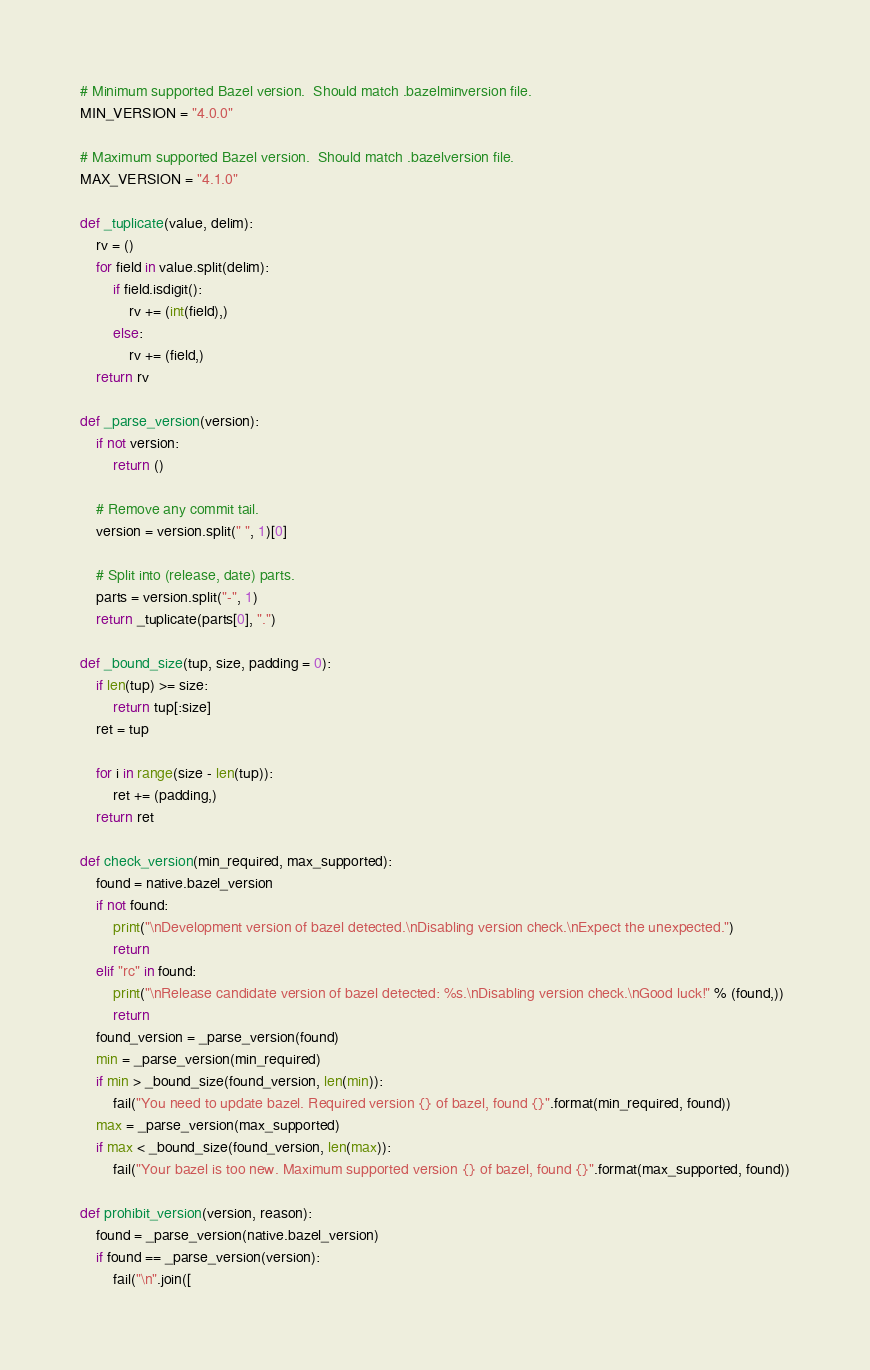<code> <loc_0><loc_0><loc_500><loc_500><_Python_># Minimum supported Bazel version.  Should match .bazelminversion file.
MIN_VERSION = "4.0.0"

# Maximum supported Bazel version.  Should match .bazelversion file.
MAX_VERSION = "4.1.0"

def _tuplicate(value, delim):
    rv = ()
    for field in value.split(delim):
        if field.isdigit():
            rv += (int(field),)
        else:
            rv += (field,)
    return rv

def _parse_version(version):
    if not version:
        return ()

    # Remove any commit tail.
    version = version.split(" ", 1)[0]

    # Split into (release, date) parts.
    parts = version.split("-", 1)
    return _tuplicate(parts[0], ".")

def _bound_size(tup, size, padding = 0):
    if len(tup) >= size:
        return tup[:size]
    ret = tup

    for i in range(size - len(tup)):
        ret += (padding,)
    return ret

def check_version(min_required, max_supported):
    found = native.bazel_version
    if not found:
        print("\nDevelopment version of bazel detected.\nDisabling version check.\nExpect the unexpected.")
        return
    elif "rc" in found:
        print("\nRelease candidate version of bazel detected: %s.\nDisabling version check.\nGood luck!" % (found,))
        return
    found_version = _parse_version(found)
    min = _parse_version(min_required)
    if min > _bound_size(found_version, len(min)):
        fail("You need to update bazel. Required version {} of bazel, found {}".format(min_required, found))
    max = _parse_version(max_supported)
    if max < _bound_size(found_version, len(max)):
        fail("Your bazel is too new. Maximum supported version {} of bazel, found {}".format(max_supported, found))

def prohibit_version(version, reason):
    found = _parse_version(native.bazel_version)
    if found == _parse_version(version):
        fail("\n".join([</code> 